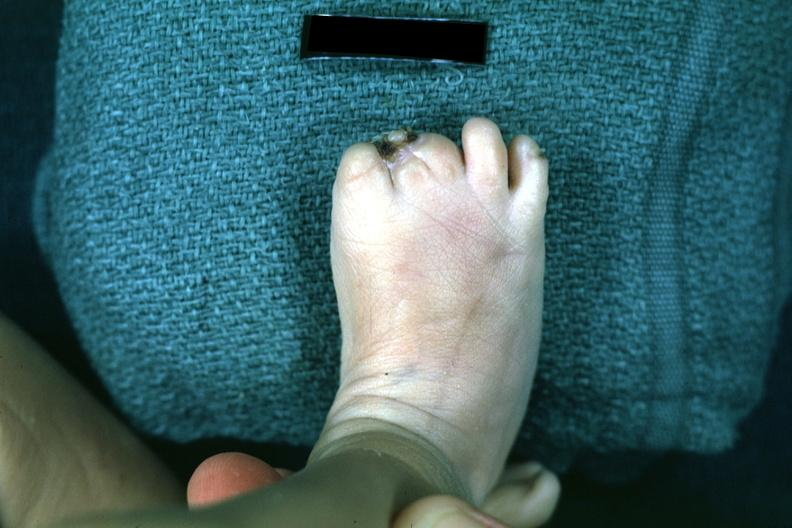what is present?
Answer the question using a single word or phrase. Foot 